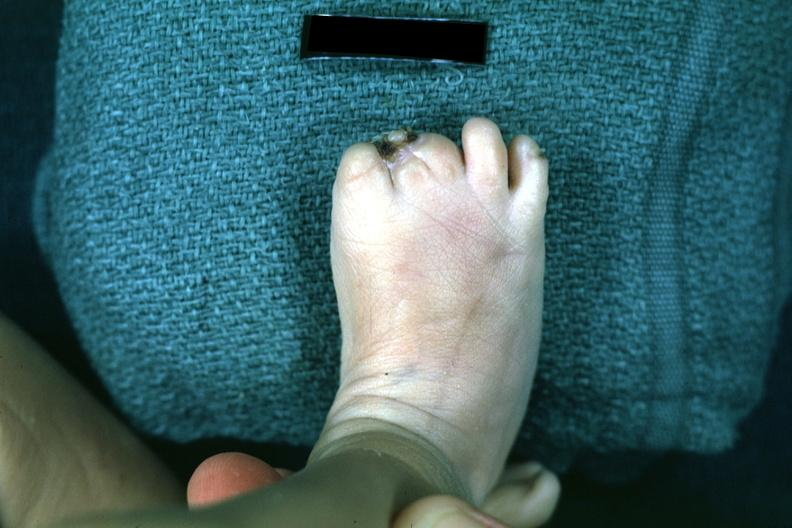what is present?
Answer the question using a single word or phrase. Foot 